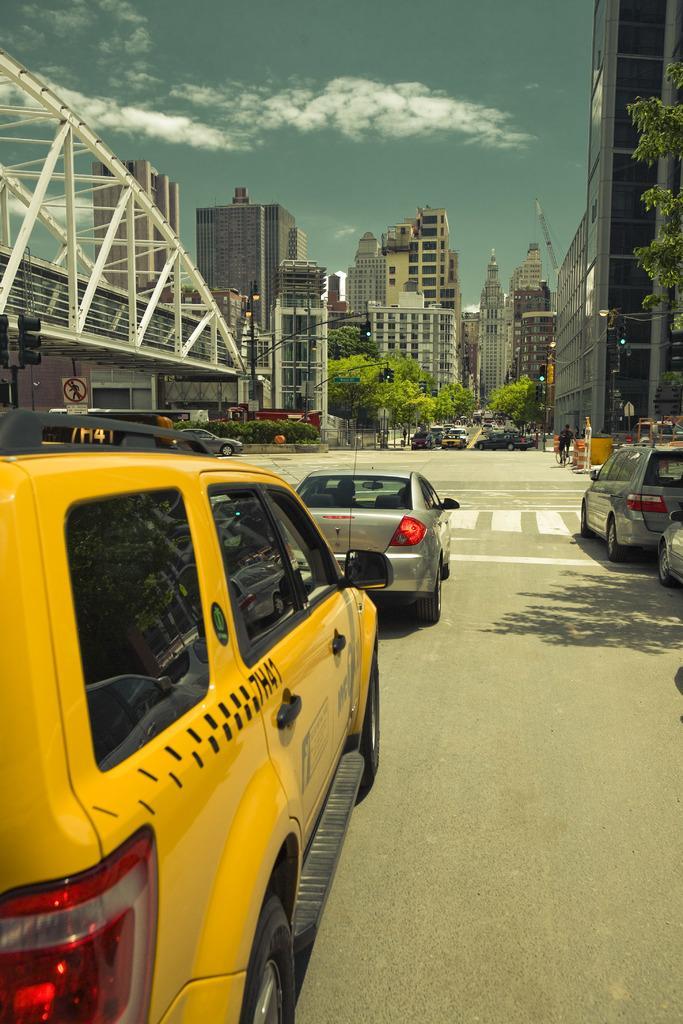In one or two sentences, can you explain what this image depicts? In the image there are few cars on the road, in the back there are trees with buildings in front of it and above its sky with clouds. 